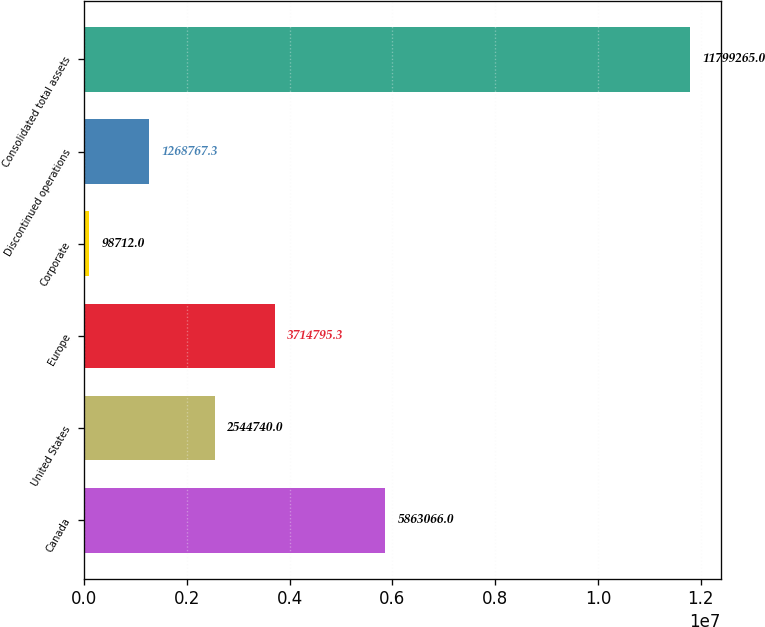Convert chart. <chart><loc_0><loc_0><loc_500><loc_500><bar_chart><fcel>Canada<fcel>United States<fcel>Europe<fcel>Corporate<fcel>Discontinued operations<fcel>Consolidated total assets<nl><fcel>5.86307e+06<fcel>2.54474e+06<fcel>3.7148e+06<fcel>98712<fcel>1.26877e+06<fcel>1.17993e+07<nl></chart> 